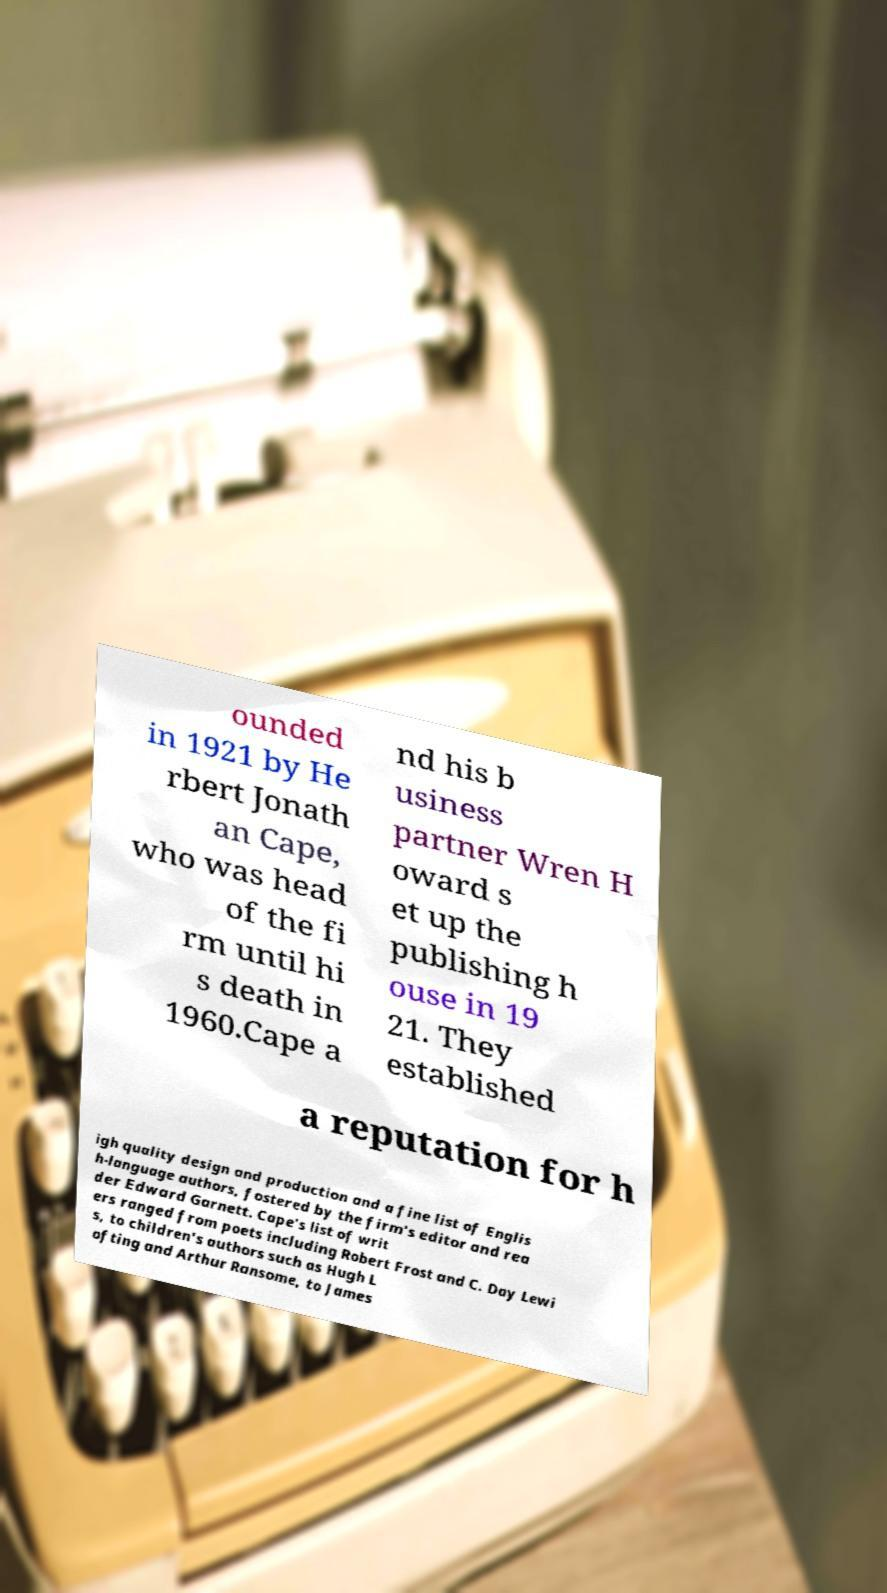Could you extract and type out the text from this image? ounded in 1921 by He rbert Jonath an Cape, who was head of the fi rm until hi s death in 1960.Cape a nd his b usiness partner Wren H oward s et up the publishing h ouse in 19 21. They established a reputation for h igh quality design and production and a fine list of Englis h-language authors, fostered by the firm's editor and rea der Edward Garnett. Cape's list of writ ers ranged from poets including Robert Frost and C. Day Lewi s, to children's authors such as Hugh L ofting and Arthur Ransome, to James 